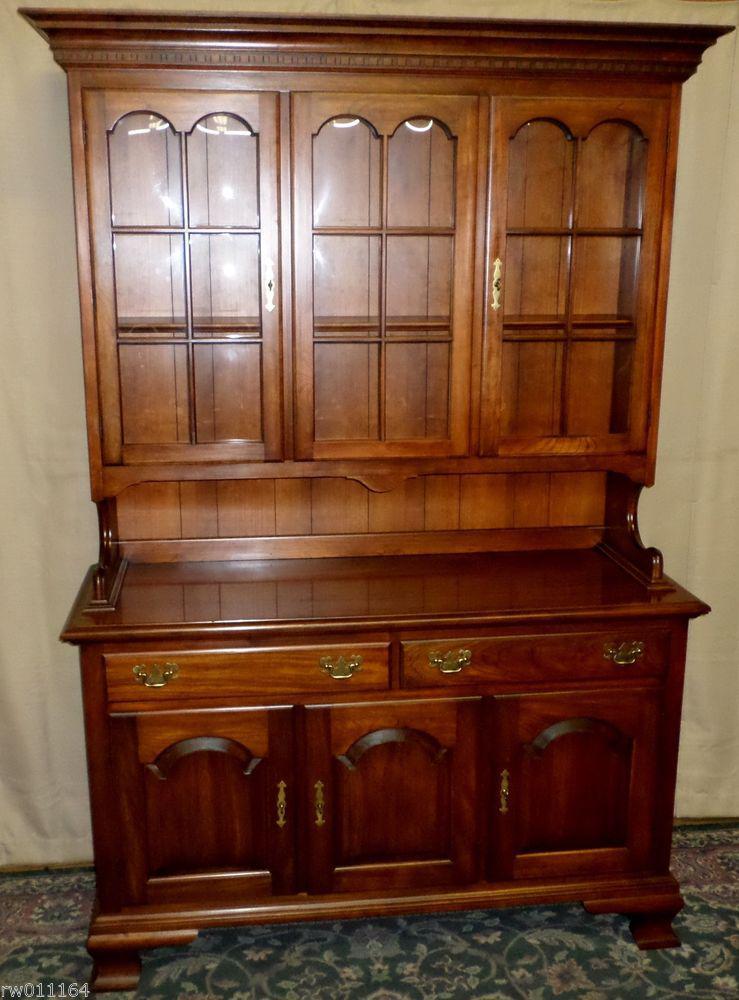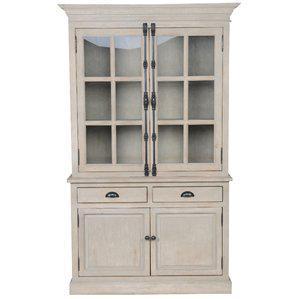The first image is the image on the left, the second image is the image on the right. Evaluate the accuracy of this statement regarding the images: "An image shows a cabinet with a non-flat top and with feet.". Is it true? Answer yes or no. No. The first image is the image on the left, the second image is the image on the right. For the images displayed, is the sentence "In one image, a wooden hutch sits on short legs and has three doors at the top, three at the bottom, and two drawers in the middle." factually correct? Answer yes or no. Yes. 